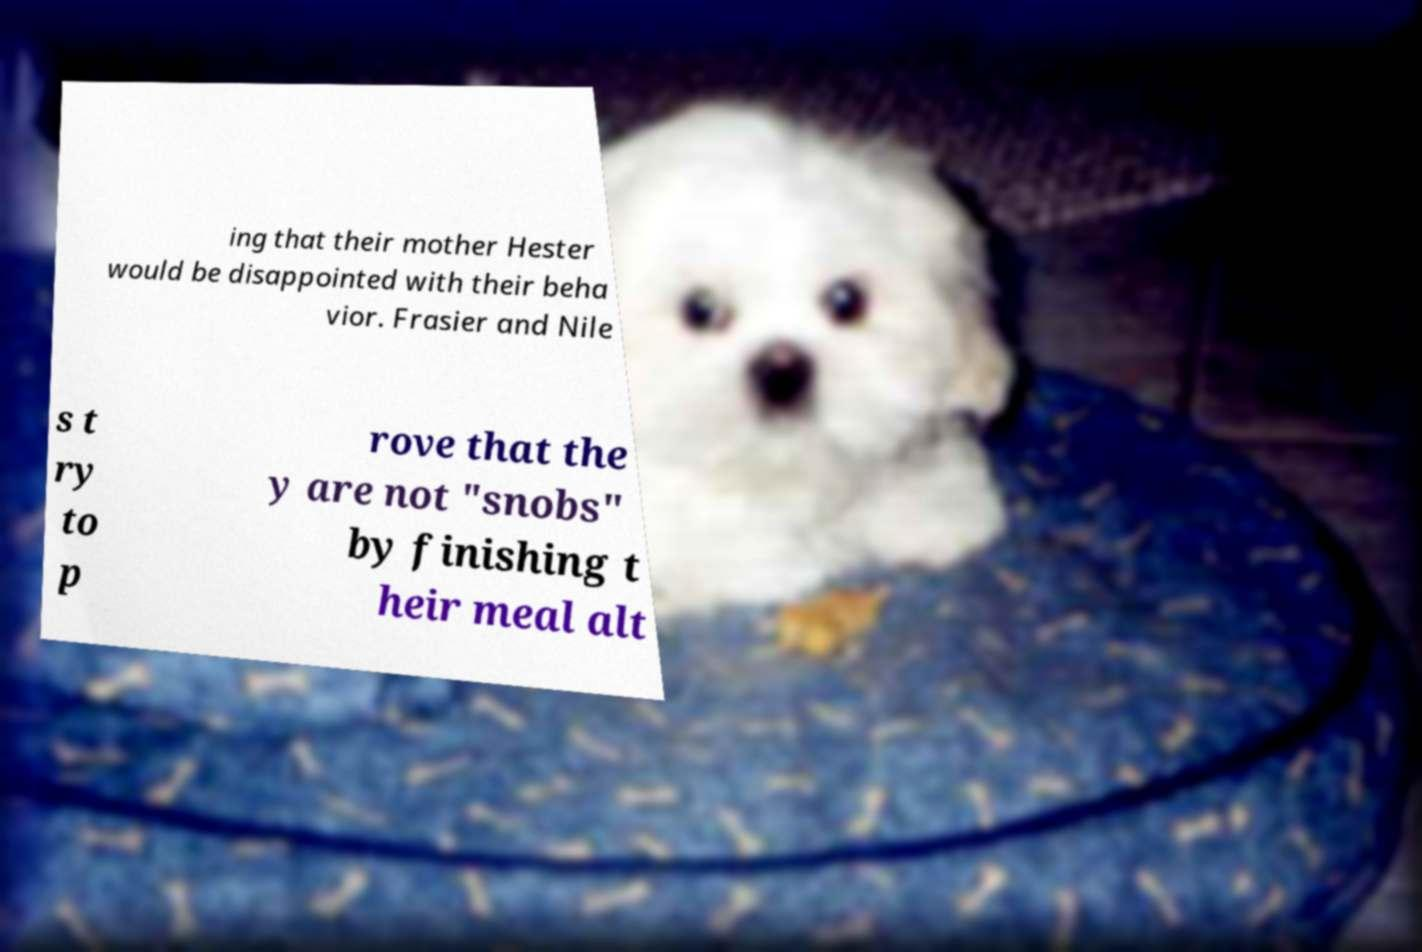Could you assist in decoding the text presented in this image and type it out clearly? ing that their mother Hester would be disappointed with their beha vior. Frasier and Nile s t ry to p rove that the y are not "snobs" by finishing t heir meal alt 